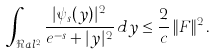Convert formula to latex. <formula><loc_0><loc_0><loc_500><loc_500>\int _ { \Re a l ^ { 2 } } \frac { | \psi _ { s } ( y ) | ^ { 2 } } { e ^ { - s } + | y | ^ { 2 } } \, d y \leq \frac { 2 } { c } \, \| F \| ^ { 2 } \, .</formula> 